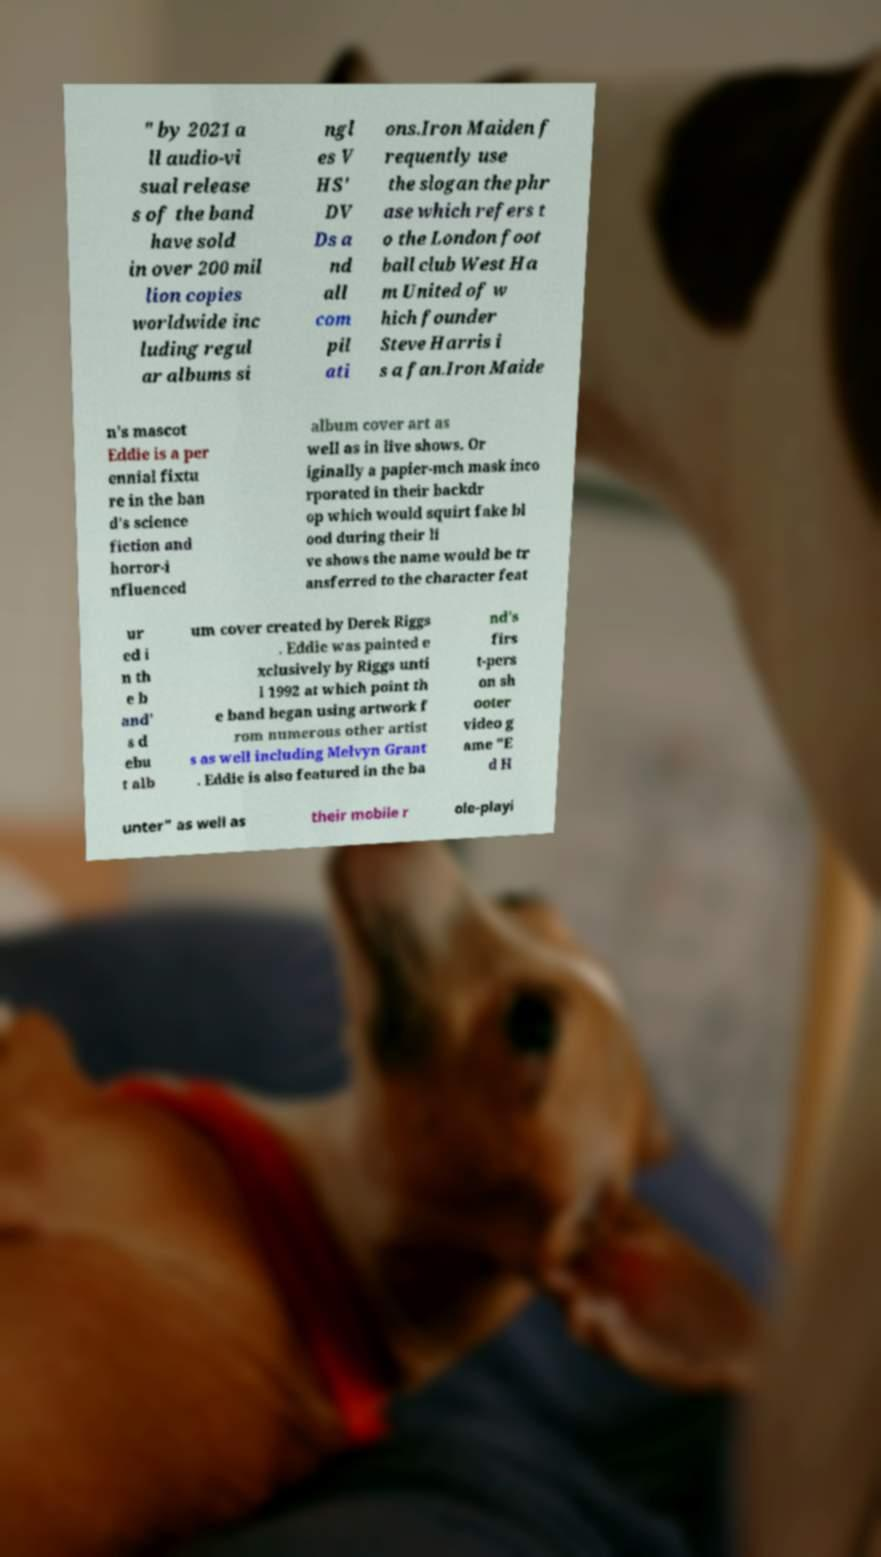Could you assist in decoding the text presented in this image and type it out clearly? " by 2021 a ll audio-vi sual release s of the band have sold in over 200 mil lion copies worldwide inc luding regul ar albums si ngl es V HS' DV Ds a nd all com pil ati ons.Iron Maiden f requently use the slogan the phr ase which refers t o the London foot ball club West Ha m United of w hich founder Steve Harris i s a fan.Iron Maide n's mascot Eddie is a per ennial fixtu re in the ban d's science fiction and horror-i nfluenced album cover art as well as in live shows. Or iginally a papier-mch mask inco rporated in their backdr op which would squirt fake bl ood during their li ve shows the name would be tr ansferred to the character feat ur ed i n th e b and' s d ebu t alb um cover created by Derek Riggs . Eddie was painted e xclusively by Riggs unti l 1992 at which point th e band began using artwork f rom numerous other artist s as well including Melvyn Grant . Eddie is also featured in the ba nd's firs t-pers on sh ooter video g ame "E d H unter" as well as their mobile r ole-playi 